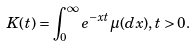Convert formula to latex. <formula><loc_0><loc_0><loc_500><loc_500>K ( t ) = \int _ { 0 } ^ { \infty } e ^ { - x t } \mu ( d x ) , t > 0 .</formula> 